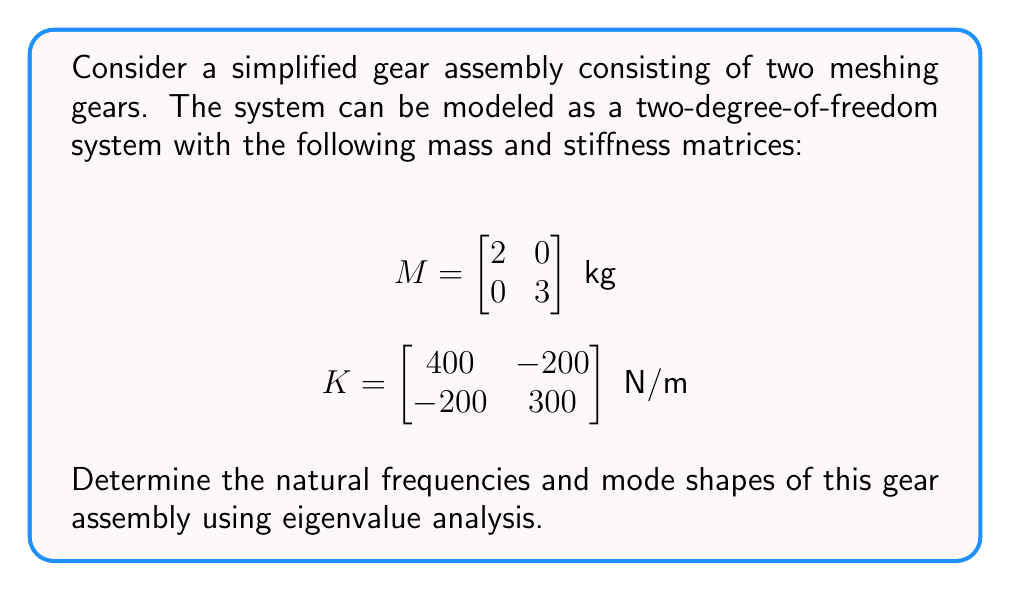What is the answer to this math problem? To analyze the vibration modes of this gear assembly, we need to solve the eigenvalue problem:

$$(K - \omega^2 M)\phi = 0$$

where $\omega$ are the natural frequencies and $\phi$ are the mode shapes (eigenvectors).

Step 1: Set up the characteristic equation
$\det(K - \omega^2 M) = 0$

Step 2: Expand the determinant
$\det\begin{bmatrix} 400 - 2\omega^2 & -200 \\ -200 & 300 - 3\omega^2 \end{bmatrix} = 0$

$(400 - 2\omega^2)(300 - 3\omega^2) - (-200)(-200) = 0$

Step 3: Solve the resulting quadratic equation in $\omega^2$
$6\omega^4 - 2100\omega^2 + 80000 = 0$

Using the quadratic formula, we get:
$\omega^2 = \frac{2100 \pm \sqrt{2100^2 - 4(6)(80000)}}{2(6)}$

$\omega^2 = \frac{2100 \pm \sqrt{4410000 - 1920000}}{12}$

$\omega^2 = \frac{2100 \pm \sqrt{2490000}}{12}$

$\omega^2 = \frac{2100 \pm 1578.0}{12}$

Step 4: Calculate the natural frequencies
$\omega_1^2 = \frac{2100 - 1578.0}{12} = 43.5 \text{ rad}^2/\text{s}^2$
$\omega_2^2 = \frac{2100 + 1578.0}{12} = 306.5 \text{ rad}^2/\text{s}^2$

$\omega_1 = \sqrt{43.5} = 6.60 \text{ rad/s}$
$\omega_2 = \sqrt{306.5} = 17.51 \text{ rad/s}$

Step 5: Find the mode shapes (eigenvectors)
For each $\omega^2$, solve $(K - \omega^2 M)\phi = 0$

For $\omega_1^2 = 43.5$:
$\begin{bmatrix} 400 - 2(43.5) & -200 \\ -200 & 300 - 3(43.5) \end{bmatrix} \begin{bmatrix} \phi_{11} \\ \phi_{21} \end{bmatrix} = \begin{bmatrix} 0 \\ 0 \end{bmatrix}$

$\begin{bmatrix} 313 & -200 \\ -200 & 169.5 \end{bmatrix} \begin{bmatrix} \phi_{11} \\ \phi_{21} \end{bmatrix} = \begin{bmatrix} 0 \\ 0 \end{bmatrix}$

Solving this system, we get $\phi_1 = \begin{bmatrix} 0.707 \\ 1 \end{bmatrix}$

For $\omega_2^2 = 306.5$:
$\begin{bmatrix} 400 - 2(306.5) & -200 \\ -200 & 300 - 3(306.5) \end{bmatrix} \begin{bmatrix} \phi_{12} \\ \phi_{22} \end{bmatrix} = \begin{bmatrix} 0 \\ 0 \end{bmatrix}$

$\begin{bmatrix} -213 & -200 \\ -200 & -619.5 \end{bmatrix} \begin{bmatrix} \phi_{12} \\ \phi_{22} \end{bmatrix} = \begin{bmatrix} 0 \\ 0 \end{bmatrix}$

Solving this system, we get $\phi_2 = \begin{bmatrix} 1 \\ -0.344 \end{bmatrix}$
Answer: Natural frequencies:
$\omega_1 = 6.60 \text{ rad/s}$
$\omega_2 = 17.51 \text{ rad/s}$

Mode shapes (normalized):
$\phi_1 = \begin{bmatrix} 0.707 \\ 1 \end{bmatrix}$
$\phi_2 = \begin{bmatrix} 1 \\ -0.344 \end{bmatrix}$ 